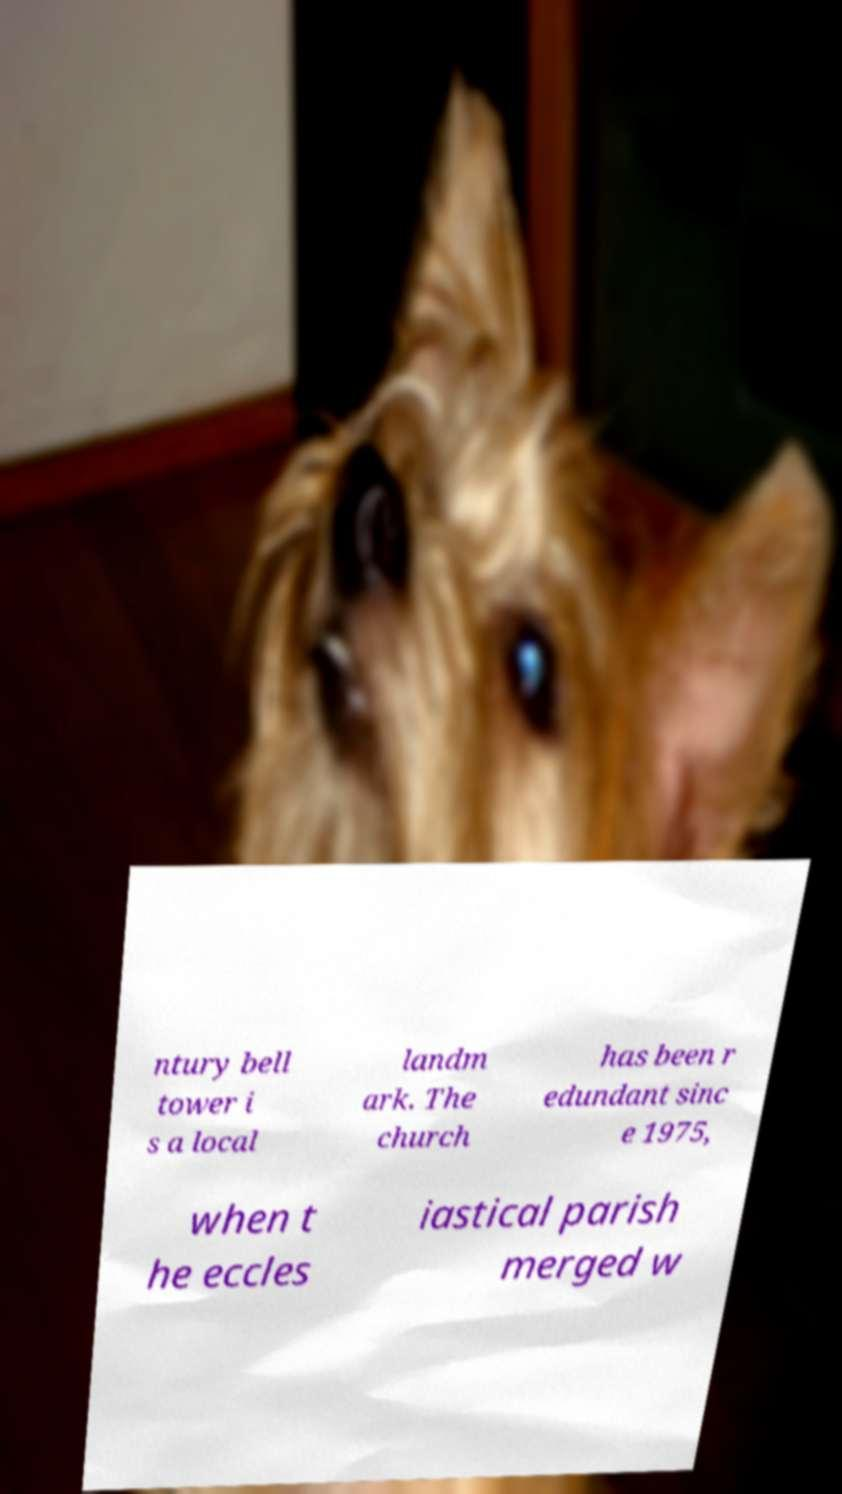I need the written content from this picture converted into text. Can you do that? ntury bell tower i s a local landm ark. The church has been r edundant sinc e 1975, when t he eccles iastical parish merged w 